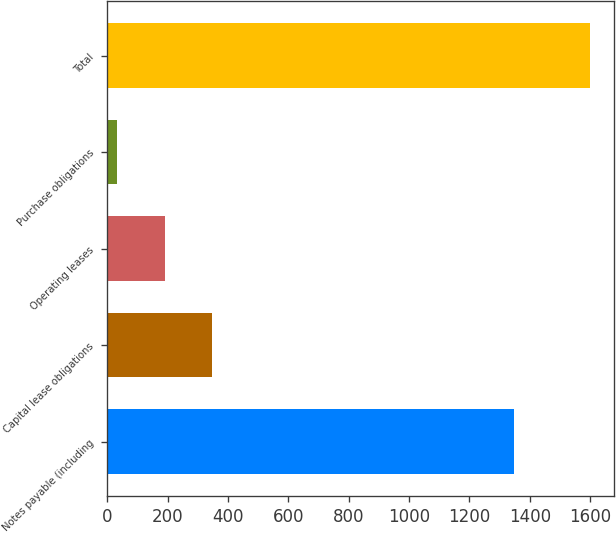Convert chart. <chart><loc_0><loc_0><loc_500><loc_500><bar_chart><fcel>Notes payable (including<fcel>Capital lease obligations<fcel>Operating leases<fcel>Purchase obligations<fcel>Total<nl><fcel>1349<fcel>346.2<fcel>189.6<fcel>33<fcel>1599<nl></chart> 